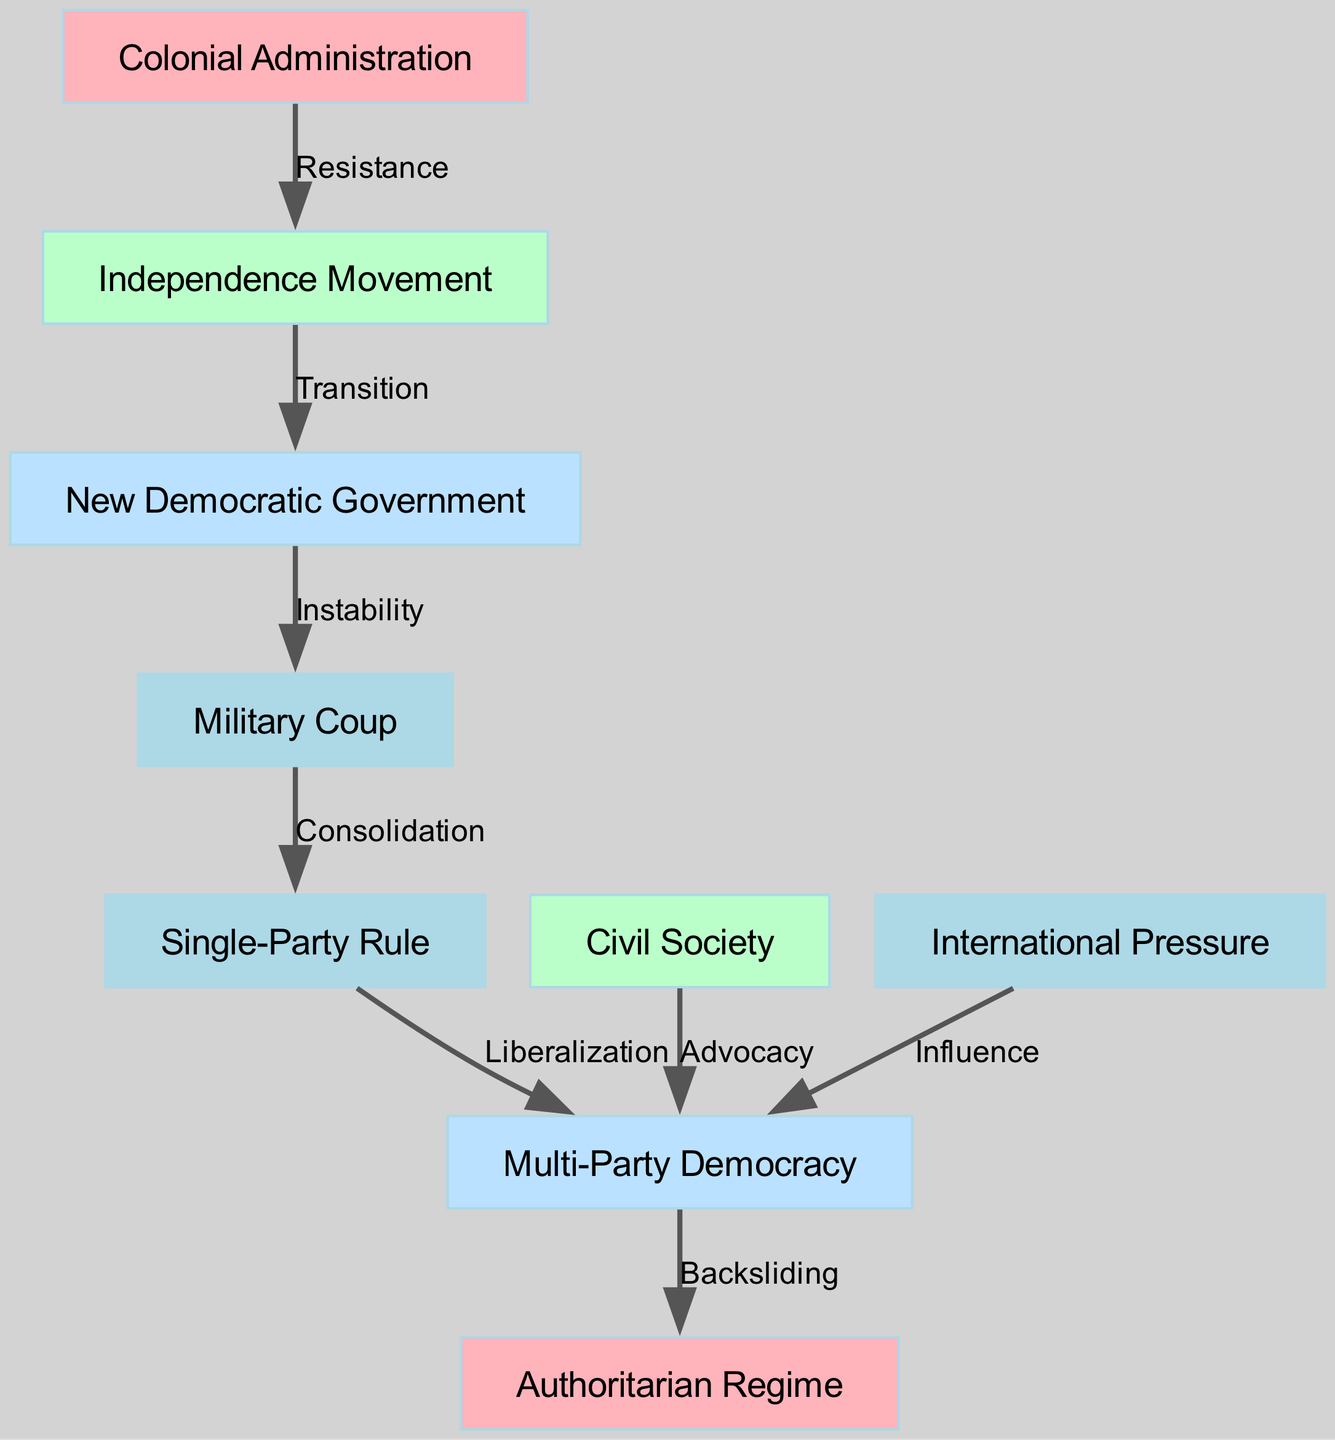What is the starting point of the power transition? The diagram indicates that the starting point of the power transition is the "Colonial Administration," signaling the initial governance structure before any movements toward independence.
Answer: Colonial Administration How many nodes are in the diagram? By counting the nodes listed in the provided data, we find there are a total of nine distinct entities represented in the diagram.
Answer: 9 What is the nature of the relationship between the "Independence Movement" and the "New Democratic Government"? The diagram illustrates a direct "Transition" relationship connecting the "Independence Movement" to the "New Democratic Government," indicating a shift in power during this phase.
Answer: Transition Which node represents a setback in democratic governance? The arrow directed from "Multi-Party Democracy" to "Authoritarian Regime" is labeled "Backsliding," indicating that this node represents a setback in the democratic governance process.
Answer: Backsliding What influences the "Multi-Party Democracy"? The diagram shows both "Civil Society" and "International Pressure" having direct influence on "Multi-Party Democracy," indicating the dual sources of support for this governance structure.
Answer: Civil Society, International Pressure What follows after a "Military Coup"? The relationship directed from "Military Coup" to "Single-Party Rule" indicates that the consequence or result of a military coup in the diagram is the establishment of single-party governance.
Answer: Single-Party Rule What does "Liberalization" signify in the context of this diagram? The term "Liberalization" appears as a connecting label from "Single-Party Rule" to "Multi-Party Democracy," signifying a relaxation or opening up of governance structures towards a democratic system.
Answer: Liberalization How many edges are present in the graph? A careful examination of the edges connecting the nodes provides a total of eight directional relationships present in the diagram.
Answer: 8 What role does "Civil Society" play in the transition? "Civil Society" is shown to have an "Advocacy" relationship directing towards "Multi-Party Democracy," highlighting its role in promoting and supporting democratic governance.
Answer: Advocacy Which node depicts an early governance structure? The "Colonial Administration" is the only node that directly represents an early governance structure prior to independence movements and subsequent transitions.
Answer: Colonial Administration 